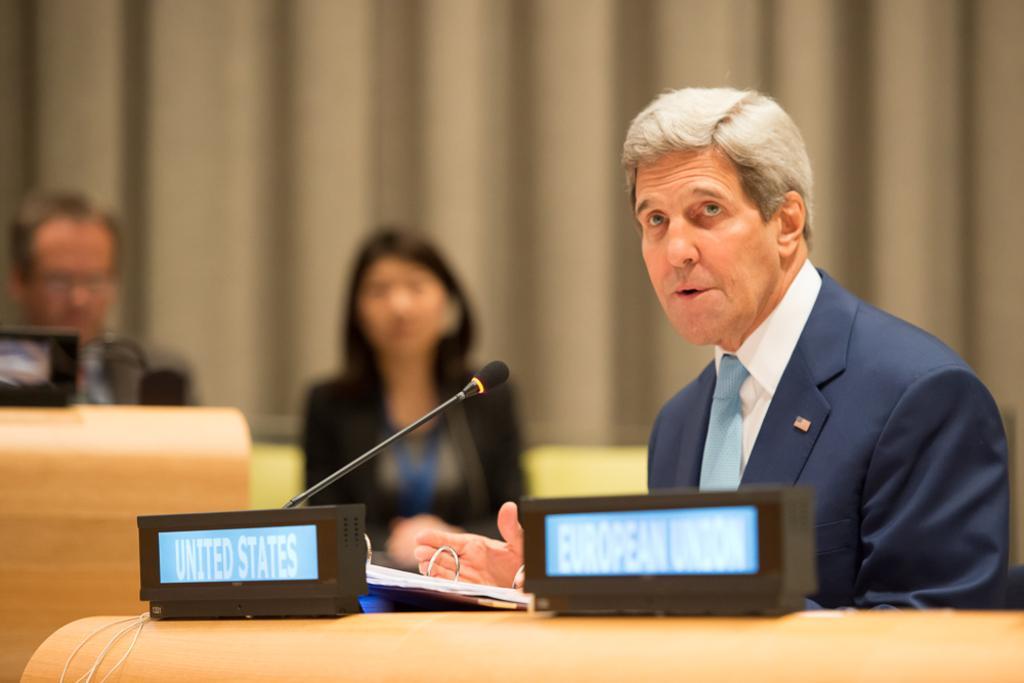Could you give a brief overview of what you see in this image? In the center of the image we can see one person sitting. In front of him, there is a table. On the table, we can see the banners, papers, one microphone, etc. In the background there is a curtain, one table, two persons are sitting and few other objects. 